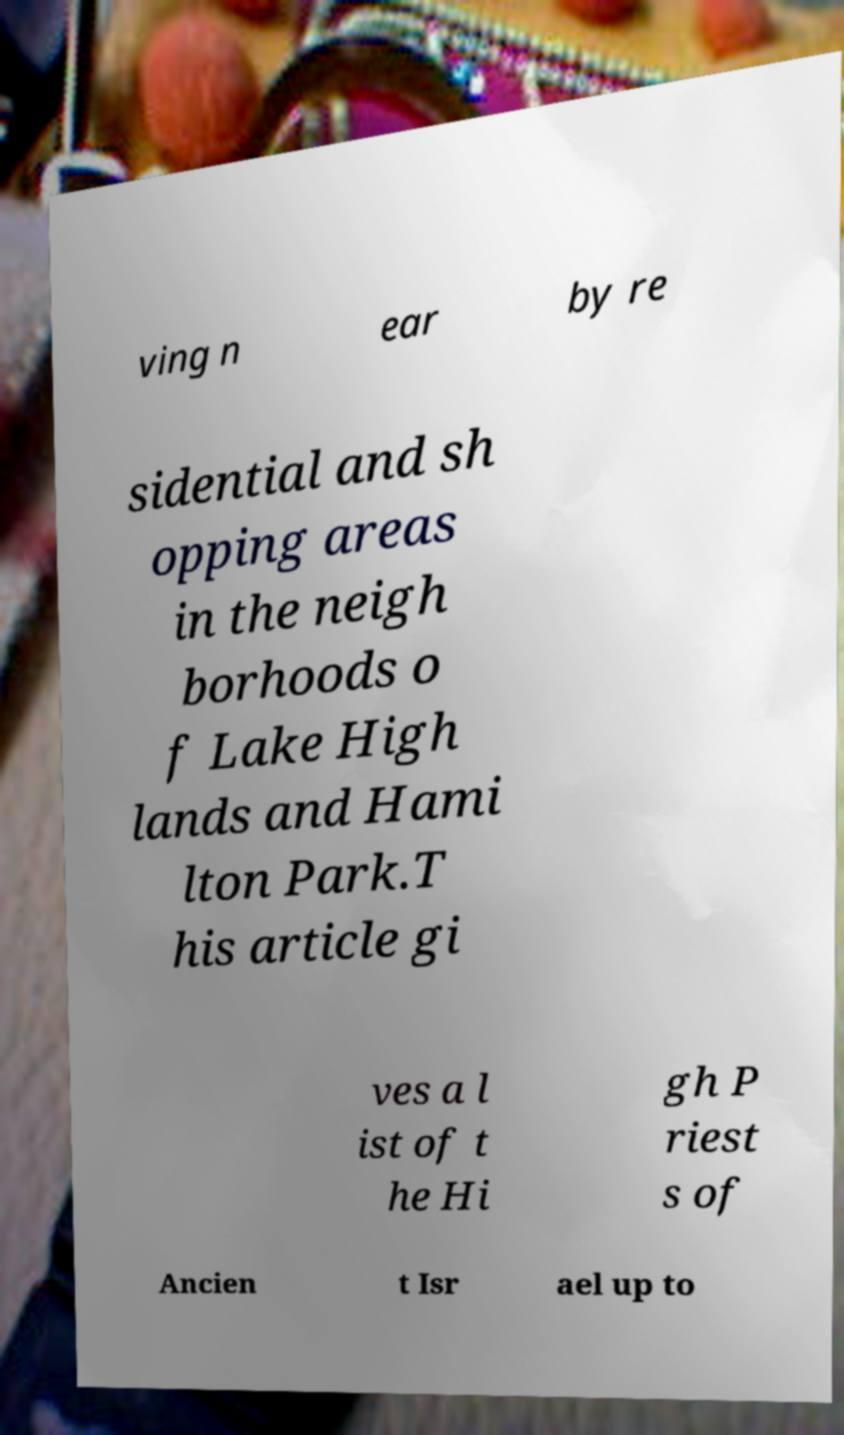For documentation purposes, I need the text within this image transcribed. Could you provide that? ving n ear by re sidential and sh opping areas in the neigh borhoods o f Lake High lands and Hami lton Park.T his article gi ves a l ist of t he Hi gh P riest s of Ancien t Isr ael up to 